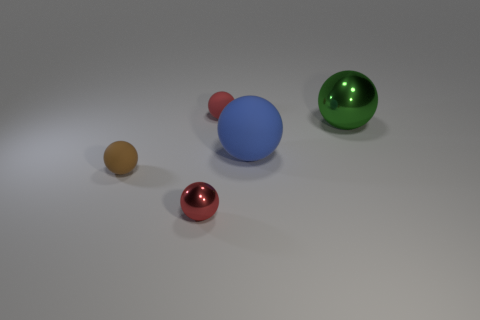What color is the small matte sphere that is behind the tiny rubber thing in front of the tiny red sphere that is behind the green sphere? There appears to be a misunderstanding as no sphere fits the exact description given. However, based on the visible spheres and their arrangement, the small matte sphere in question may not exist, and the properties of the spheres mentioned may need to be reassessed. 